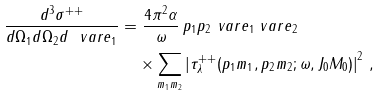Convert formula to latex. <formula><loc_0><loc_0><loc_500><loc_500>\frac { d ^ { 3 } \sigma ^ { + + } } { d \Omega _ { 1 } d \Omega _ { 2 } d \ v a r e _ { 1 } } = & \ \frac { 4 \pi ^ { 2 } \alpha } { \omega } \, p _ { 1 } p _ { 2 } \ v a r e _ { 1 } \ v a r e _ { 2 } \, \\ & \times \sum _ { m _ { 1 } m _ { 2 } } \left | \tau ^ { + + } _ { \lambda } ( p _ { 1 } m _ { 1 } , p _ { 2 } m _ { 2 } ; \omega , J _ { 0 } M _ { 0 } ) \right | ^ { 2 } \, ,</formula> 